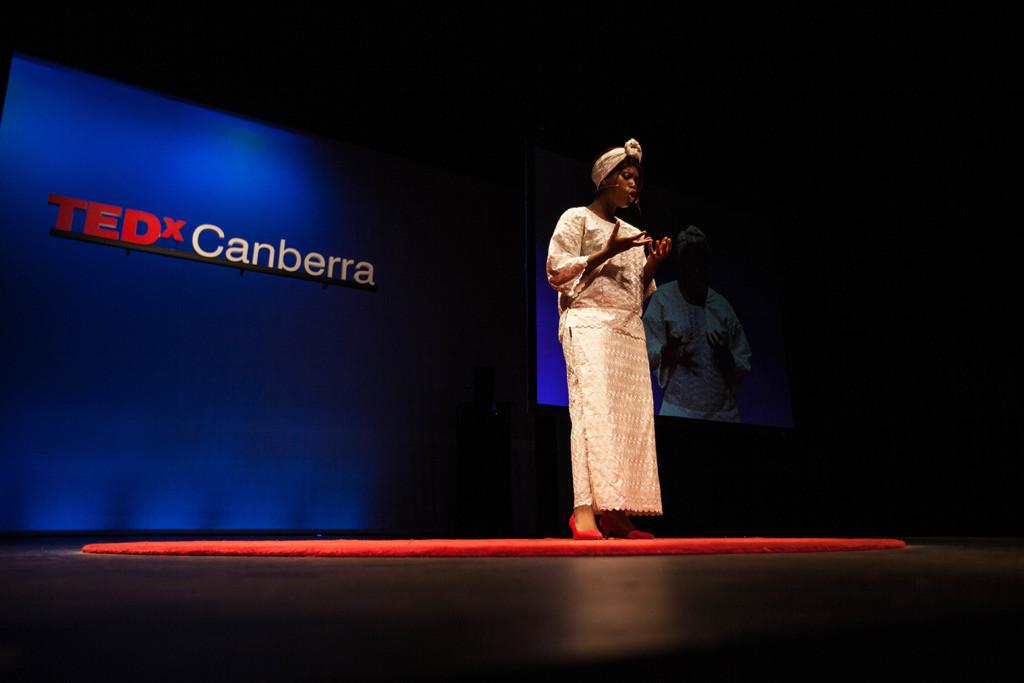Who is the main subject in the image? There is a woman in the image. What is the woman wearing? The woman is wearing a cream-colored dress. What is the woman doing in the image? The woman is standing. What can be seen behind the woman? There is something written behind the woman. What else is visible in the background of the image? There is another image in the background. Is the woman wearing a hat in the image? There is no hat visible on the woman in the image. What achievements is the woman being recognized for in the image? There is no indication in the image that the woman is being recognized for any achievements. 